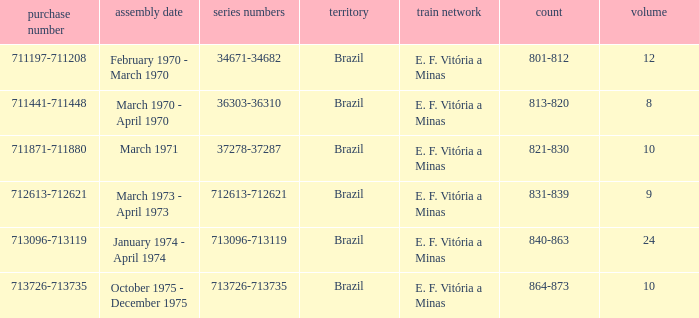What are the numbers for the order number 713096-713119? 840-863. 